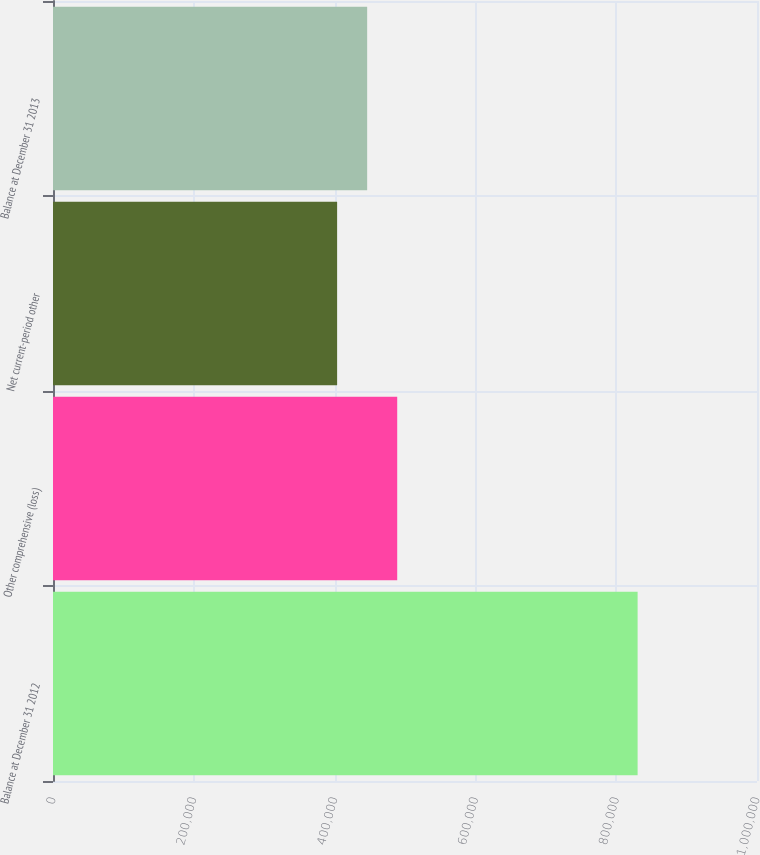Convert chart to OTSL. <chart><loc_0><loc_0><loc_500><loc_500><bar_chart><fcel>Balance at December 31 2012<fcel>Other comprehensive (loss)<fcel>Net current-period other<fcel>Balance at December 31 2013<nl><fcel>830403<fcel>488939<fcel>403573<fcel>446256<nl></chart> 